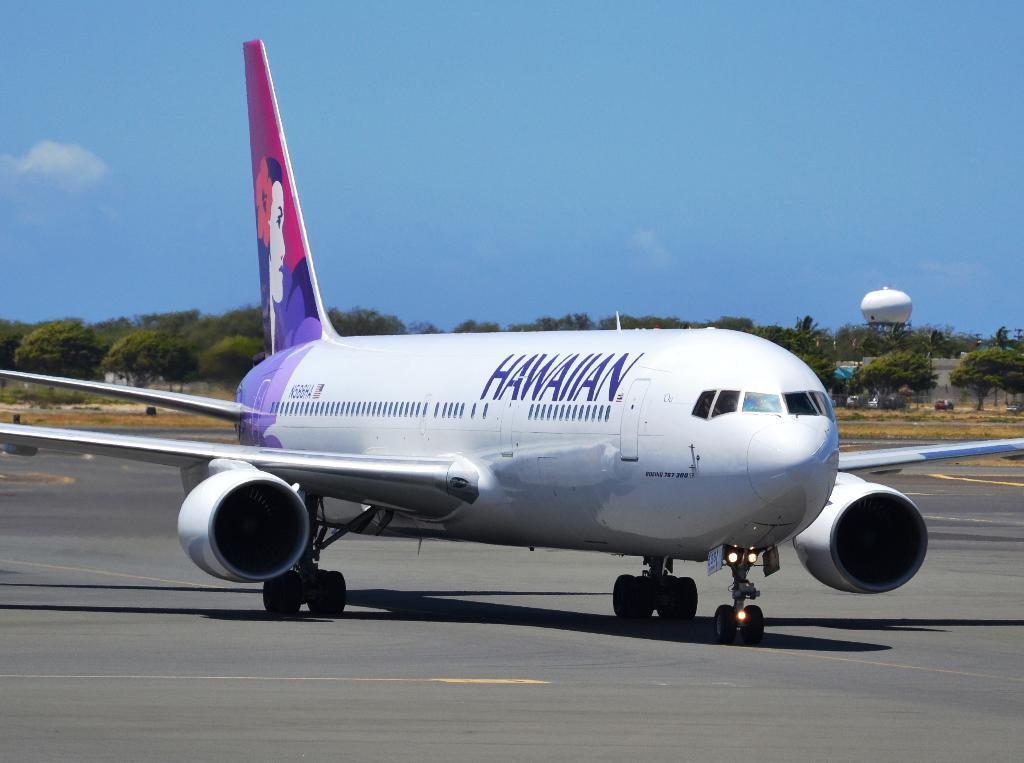<image>
Relay a brief, clear account of the picture shown. A Hawaiian air jet takes off from a run way. 